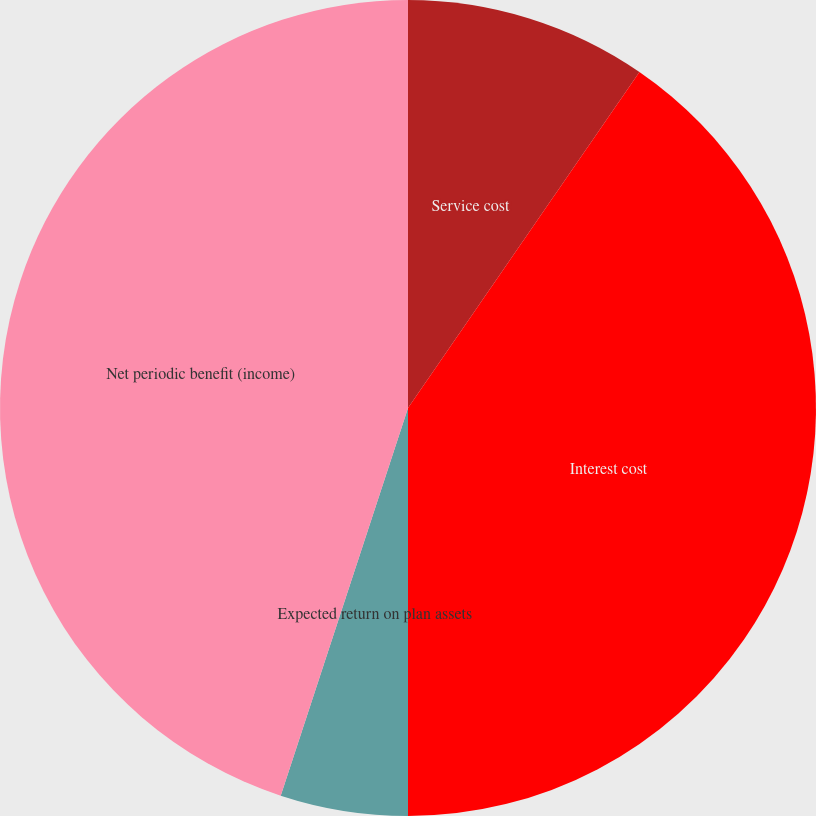<chart> <loc_0><loc_0><loc_500><loc_500><pie_chart><fcel>Service cost<fcel>Interest cost<fcel>Expected return on plan assets<fcel>Net periodic benefit (income)<nl><fcel>9.6%<fcel>40.4%<fcel>5.05%<fcel>44.95%<nl></chart> 